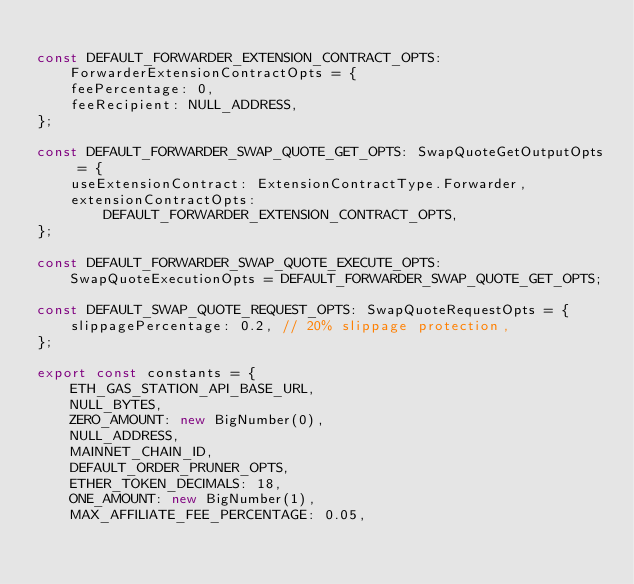<code> <loc_0><loc_0><loc_500><loc_500><_TypeScript_>
const DEFAULT_FORWARDER_EXTENSION_CONTRACT_OPTS: ForwarderExtensionContractOpts = {
    feePercentage: 0,
    feeRecipient: NULL_ADDRESS,
};

const DEFAULT_FORWARDER_SWAP_QUOTE_GET_OPTS: SwapQuoteGetOutputOpts = {
    useExtensionContract: ExtensionContractType.Forwarder,
    extensionContractOpts: DEFAULT_FORWARDER_EXTENSION_CONTRACT_OPTS,
};

const DEFAULT_FORWARDER_SWAP_QUOTE_EXECUTE_OPTS: SwapQuoteExecutionOpts = DEFAULT_FORWARDER_SWAP_QUOTE_GET_OPTS;

const DEFAULT_SWAP_QUOTE_REQUEST_OPTS: SwapQuoteRequestOpts = {
    slippagePercentage: 0.2, // 20% slippage protection,
};

export const constants = {
    ETH_GAS_STATION_API_BASE_URL,
    NULL_BYTES,
    ZERO_AMOUNT: new BigNumber(0),
    NULL_ADDRESS,
    MAINNET_CHAIN_ID,
    DEFAULT_ORDER_PRUNER_OPTS,
    ETHER_TOKEN_DECIMALS: 18,
    ONE_AMOUNT: new BigNumber(1),
    MAX_AFFILIATE_FEE_PERCENTAGE: 0.05,</code> 